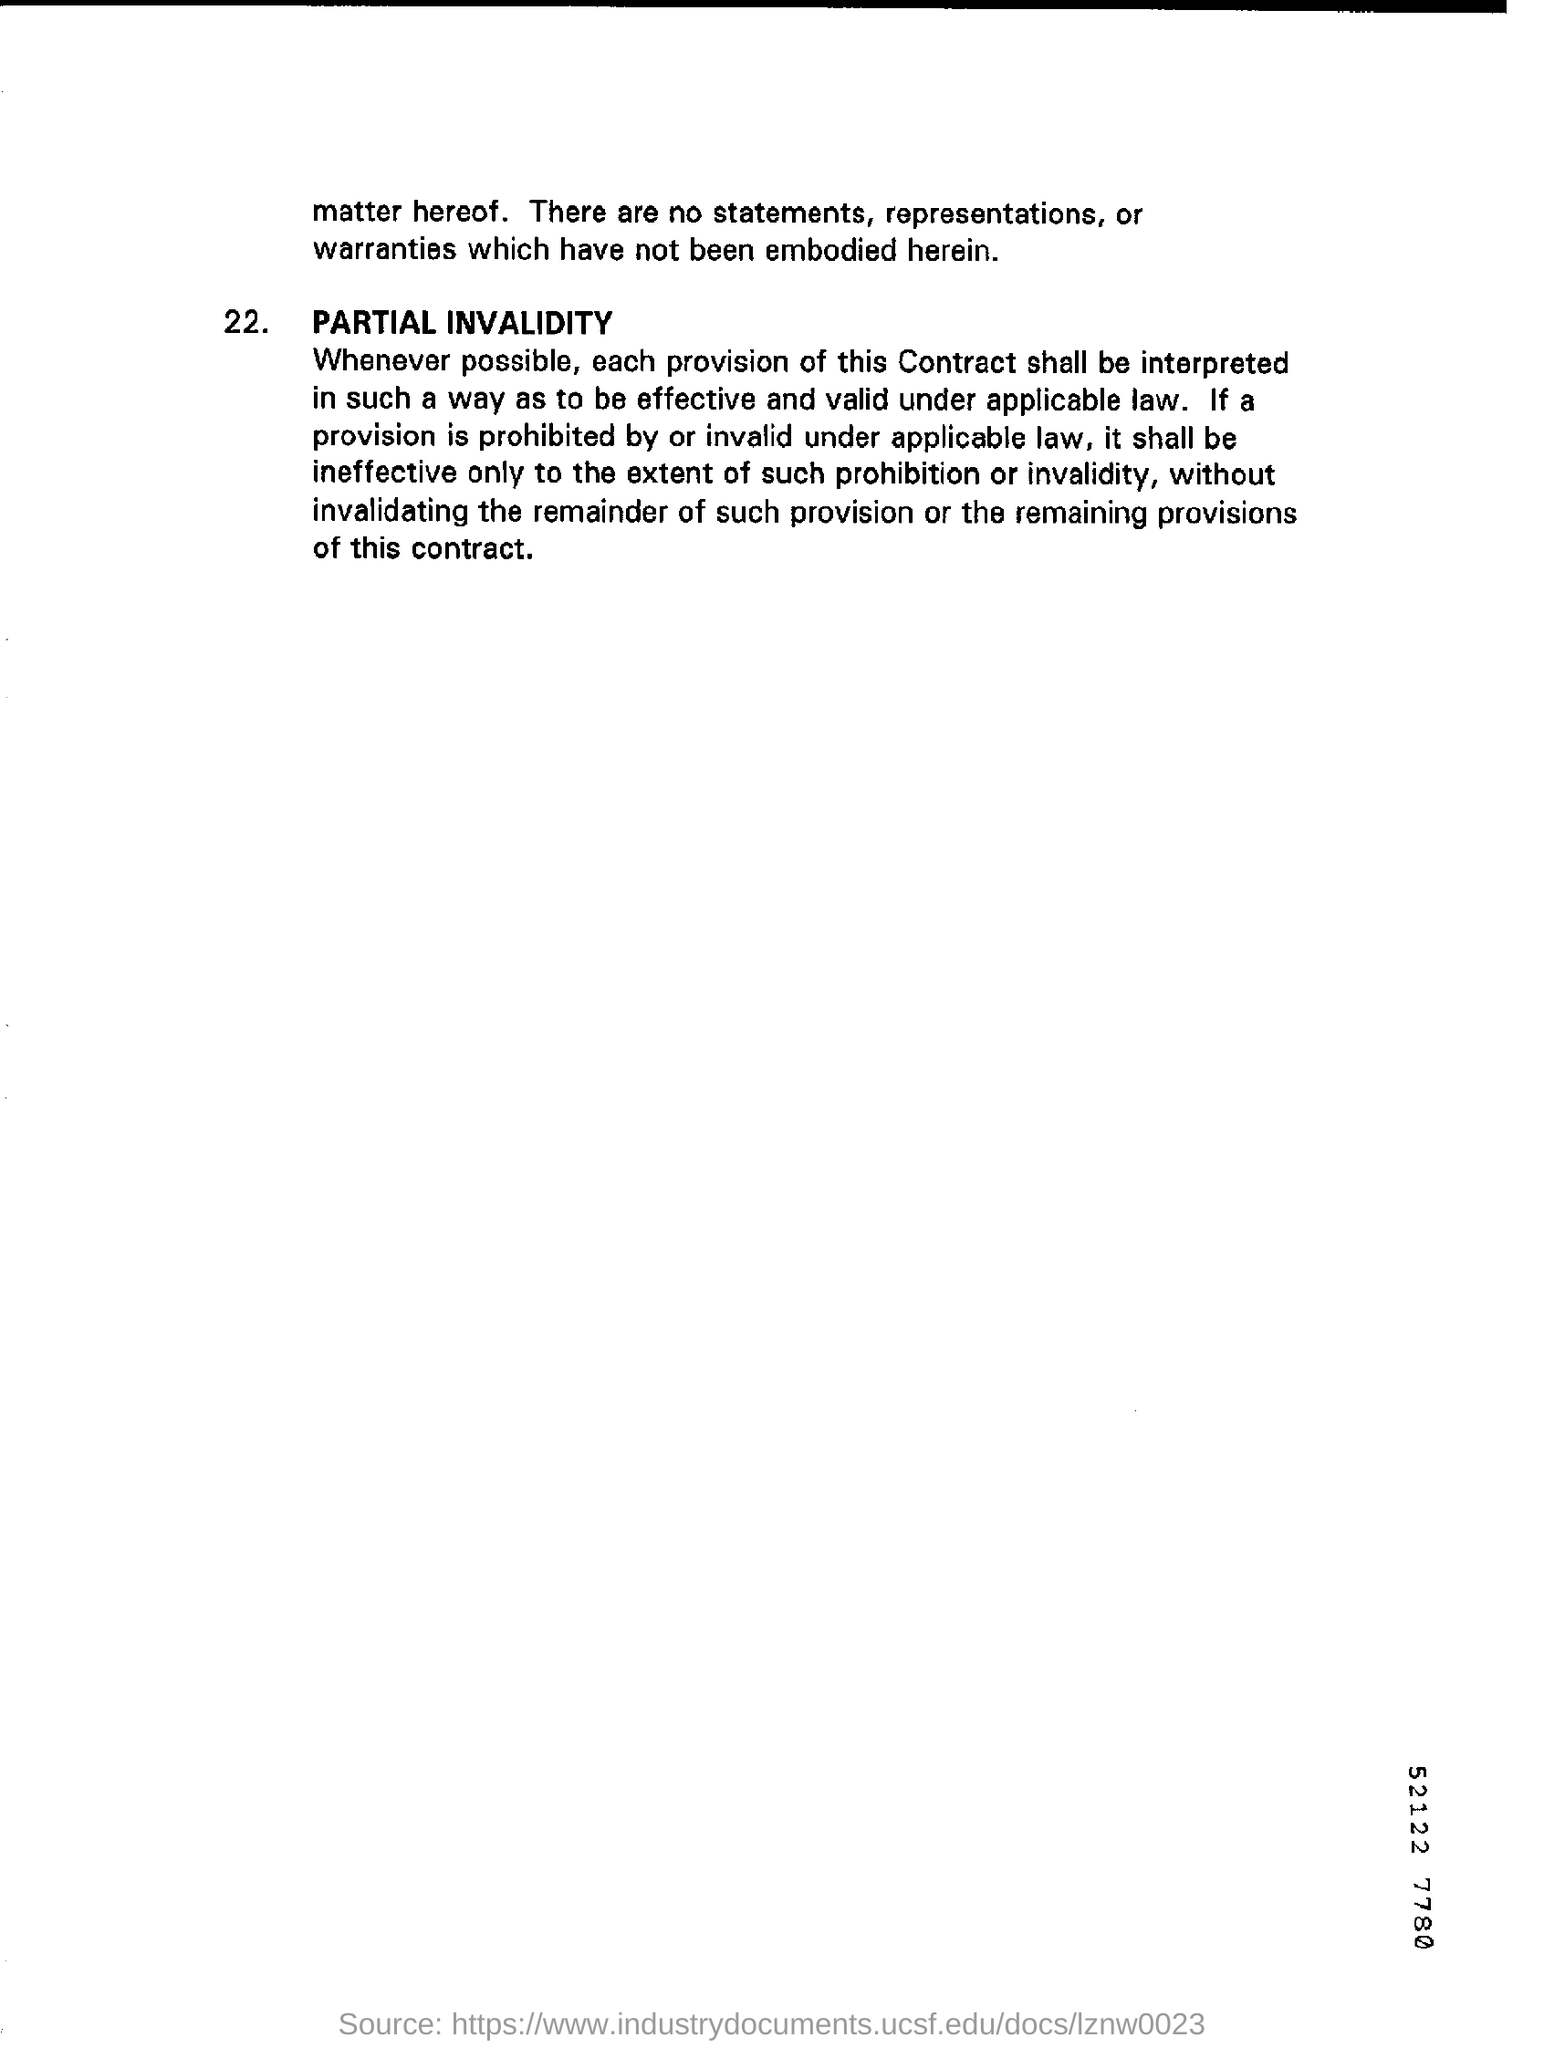Are there any statements, representations or warranties which have not been embodied herein?
Ensure brevity in your answer.  No. 